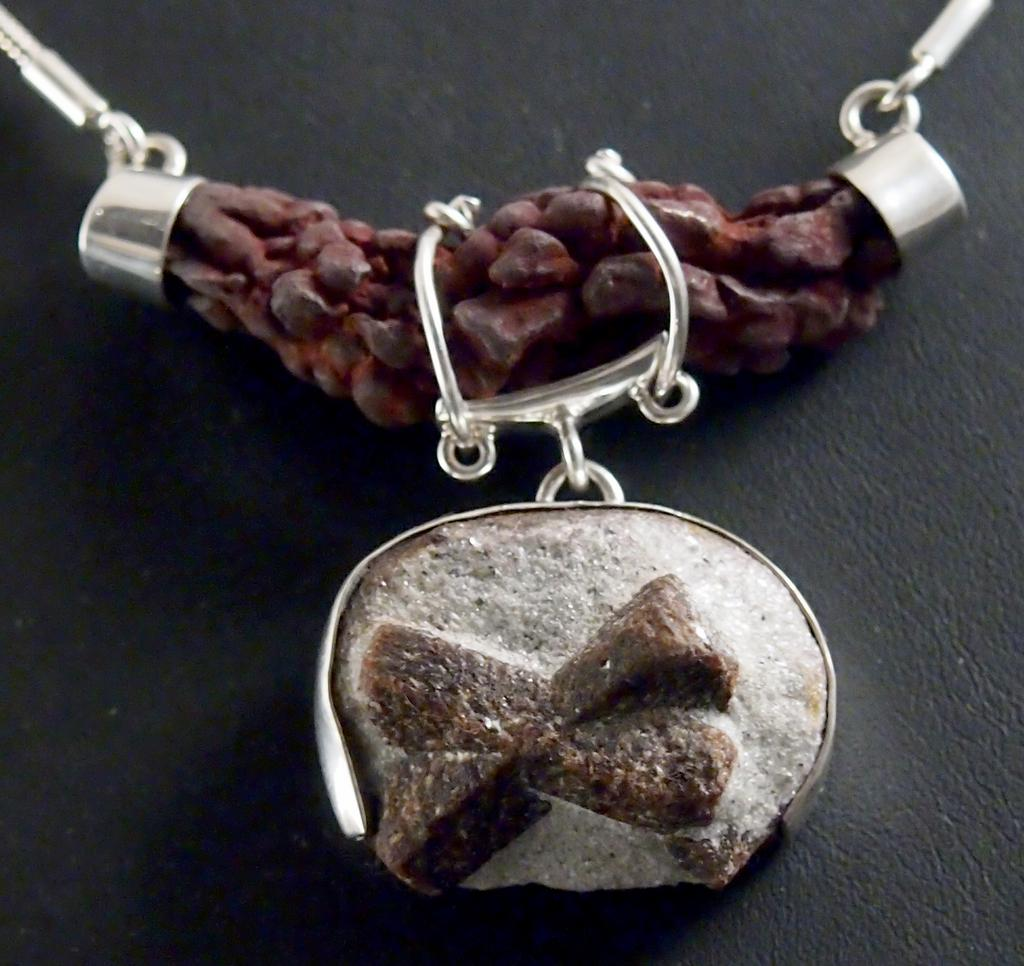What is the main object in the image? There is a locket in the image. Can you describe the position or placement of the locket? The locket is on an object. What type of corn is being weighed on the scale in the image? There is no scale or corn present in the image; it only features a locket on an object. 